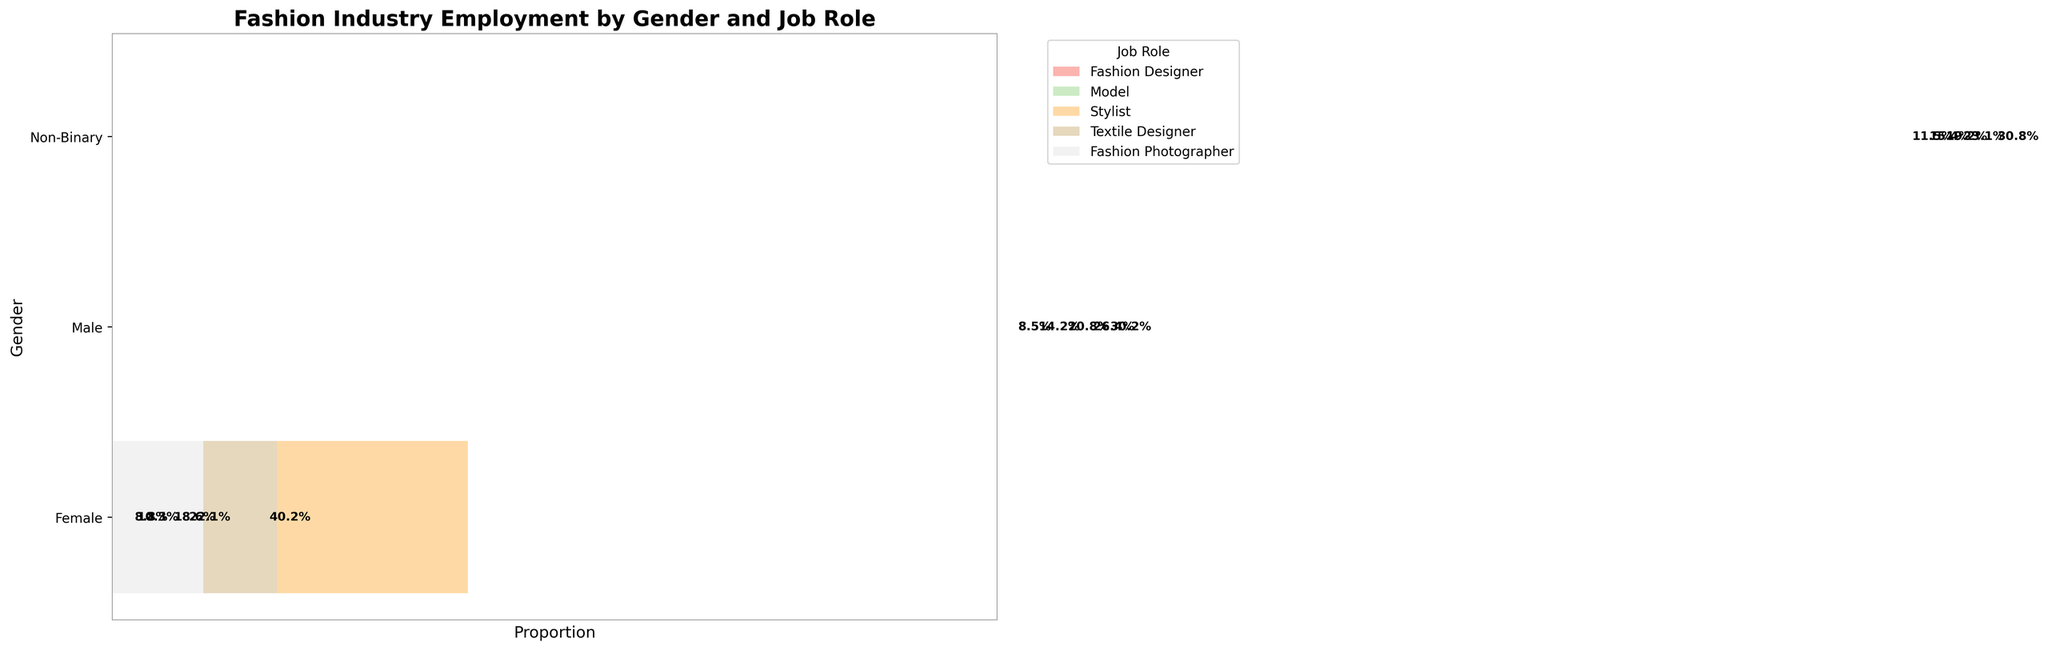What's the most common job role for females? Observe the segment lengths for each job role within the 'Female' category. The longest segment represents Models.
Answer: Model Which gender has the smallest proportion working as Textile Designers? Look at all segments representing 'Textile Designer' across different genders and compare their relative sizes. The 'Non-Binary' segment is the smallest.
Answer: Non-Binary What's the combined total percentage of Female Fashion Designers and Female Models in their gender category? Add the percentages for 'Fashion Designer' and 'Model' segments within the 'Female' category: approximately 35% + 65% = 100%.
Answer: 100% How does the percentage of Male Fashion Photographers compare to Female Fashion Photographers? Compare the relative sizes of the 'Fashion Photographer' segments between 'Male' and 'Female'. Males have a larger percentage in this role.
Answer: Males have a higher percentage What's the percentage difference in the number of Models between Females and Males? Measure the 'Model' segments for 'Female' and 'Male' categories: (820 / (450 + 820 + 380 + 210 + 180)) * 100 for females and (320 / (280 + 320 + 150 + 90 + 220)) * 100 for males. Calculate the difference.
Answer: Approximately 45% Which job role has the most balanced gender representation? Examine the segments representing each job role. The 'Fashion Photographer' roles for different genders have similar segment sizes.
Answer: Fashion Photographer How many roles do Non-Binary individuals hold compared to Females in the industry? Count the number of job roles represented in each gender category. Both 'Non-Binary' and 'Female' categories have 5 roles each.
Answer: Equal; both have 5 roles Which gender has the highest overall employment in the fashion industry shown in the plot? Observe the cumulative sizes of all segments in each gender category. The 'Female' category has the largest total segment size.
Answer: Female What proportion of Males are Stylists compared to Females? Compare the relative sizes of 'Stylist' segments within 'Male' and 'Female' categories. Male Stylists have a segment around 15%, and Female Stylists have a segment around 18%.
Answer: 15% for Males, 18% for Females How does the representation of Female Stylists compare to Male Fashion Designers? Compare the sizes of the 'Stylist' segment in the 'Female' category and 'Fashion Designer' segment in the 'Male' category. Female Stylists have a larger relative segment size than Male Designers.
Answer: Female Stylists have a higher representation 